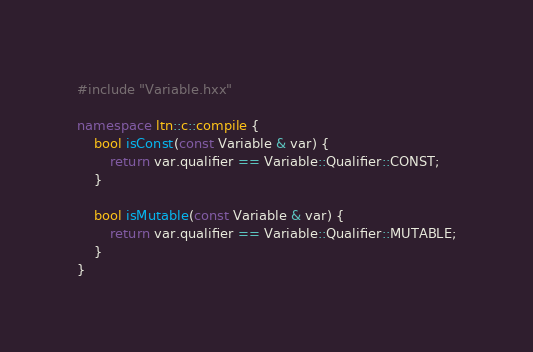<code> <loc_0><loc_0><loc_500><loc_500><_C++_>#include "Variable.hxx"

namespace ltn::c::compile {
	bool isConst(const Variable & var) {
		return var.qualifier == Variable::Qualifier::CONST;
	}

	bool isMutable(const Variable & var) {
		return var.qualifier == Variable::Qualifier::MUTABLE;
	}
}</code> 